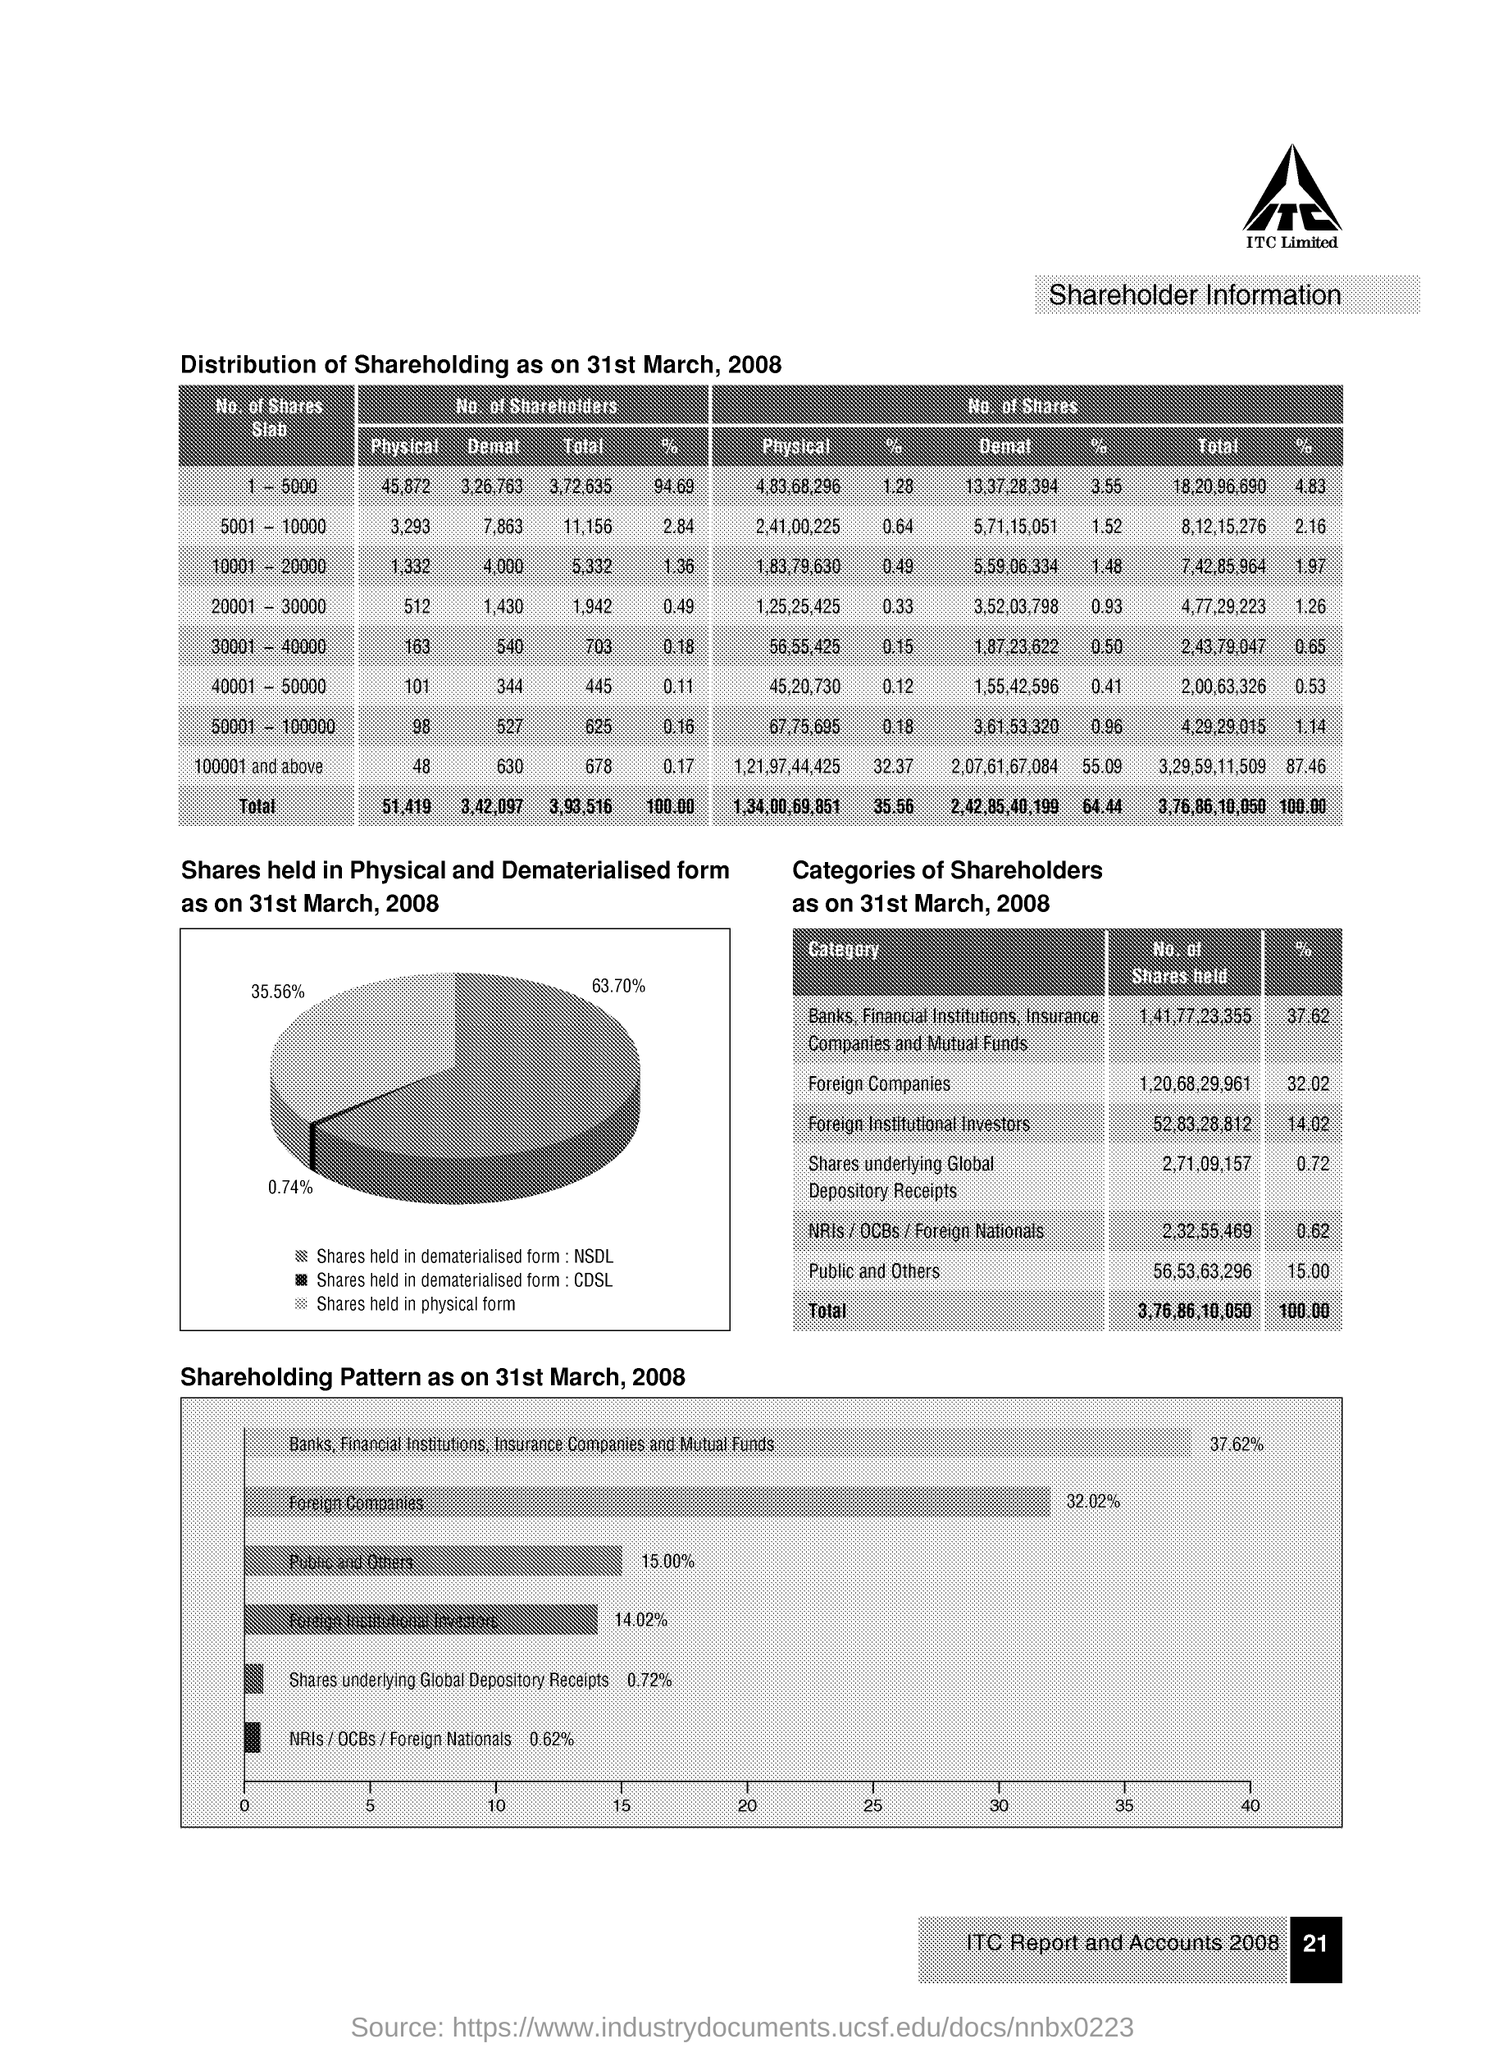What is the total no.of shareholders in the 1-5000 slab ?
Ensure brevity in your answer.  3,72,635. What is no.of physical shares in the 30001-40000 slab ?
Give a very brief answer. 56,55,425. What is the total no.of shares ?
Provide a succinct answer. 3,76,86,10,050. What percentage of shares are in 'Foreign companies' category?
Give a very brief answer. 32.02. 